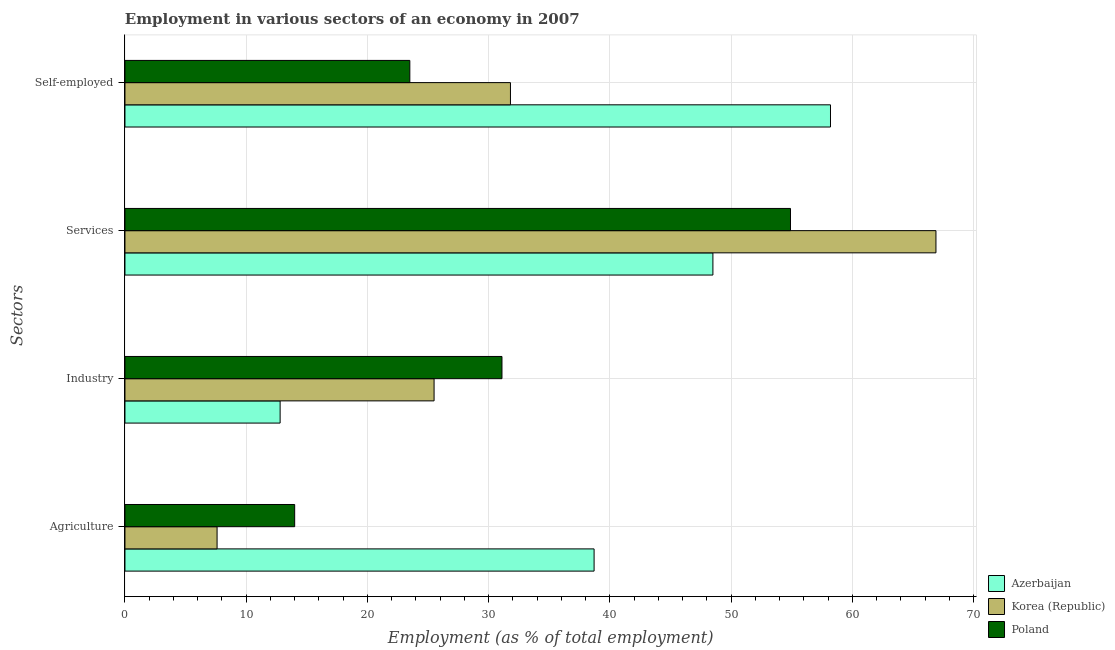How many different coloured bars are there?
Your answer should be very brief. 3. How many bars are there on the 1st tick from the bottom?
Your answer should be compact. 3. What is the label of the 1st group of bars from the top?
Ensure brevity in your answer.  Self-employed. What is the percentage of workers in agriculture in Poland?
Make the answer very short. 14. Across all countries, what is the maximum percentage of workers in agriculture?
Offer a terse response. 38.7. Across all countries, what is the minimum percentage of workers in agriculture?
Offer a terse response. 7.6. What is the total percentage of workers in agriculture in the graph?
Your response must be concise. 60.3. What is the difference between the percentage of workers in services in Korea (Republic) and that in Azerbaijan?
Your answer should be very brief. 18.4. What is the difference between the percentage of self employed workers in Poland and the percentage of workers in industry in Azerbaijan?
Your answer should be very brief. 10.7. What is the average percentage of workers in services per country?
Keep it short and to the point. 56.77. What is the difference between the percentage of workers in agriculture and percentage of self employed workers in Korea (Republic)?
Ensure brevity in your answer.  -24.2. What is the ratio of the percentage of workers in services in Korea (Republic) to that in Poland?
Your response must be concise. 1.22. Is the percentage of workers in industry in Poland less than that in Azerbaijan?
Your answer should be compact. No. Is the difference between the percentage of self employed workers in Poland and Azerbaijan greater than the difference between the percentage of workers in industry in Poland and Azerbaijan?
Your answer should be very brief. No. What is the difference between the highest and the second highest percentage of self employed workers?
Give a very brief answer. 26.4. What is the difference between the highest and the lowest percentage of workers in services?
Provide a short and direct response. 18.4. What does the 3rd bar from the top in Self-employed represents?
Your response must be concise. Azerbaijan. Is it the case that in every country, the sum of the percentage of workers in agriculture and percentage of workers in industry is greater than the percentage of workers in services?
Offer a terse response. No. Are all the bars in the graph horizontal?
Keep it short and to the point. Yes. Are the values on the major ticks of X-axis written in scientific E-notation?
Make the answer very short. No. Where does the legend appear in the graph?
Offer a very short reply. Bottom right. What is the title of the graph?
Give a very brief answer. Employment in various sectors of an economy in 2007. Does "Fragile and conflict affected situations" appear as one of the legend labels in the graph?
Your answer should be very brief. No. What is the label or title of the X-axis?
Give a very brief answer. Employment (as % of total employment). What is the label or title of the Y-axis?
Your answer should be compact. Sectors. What is the Employment (as % of total employment) in Azerbaijan in Agriculture?
Your answer should be compact. 38.7. What is the Employment (as % of total employment) of Korea (Republic) in Agriculture?
Ensure brevity in your answer.  7.6. What is the Employment (as % of total employment) of Azerbaijan in Industry?
Your answer should be compact. 12.8. What is the Employment (as % of total employment) in Poland in Industry?
Provide a succinct answer. 31.1. What is the Employment (as % of total employment) in Azerbaijan in Services?
Keep it short and to the point. 48.5. What is the Employment (as % of total employment) in Korea (Republic) in Services?
Offer a terse response. 66.9. What is the Employment (as % of total employment) of Poland in Services?
Keep it short and to the point. 54.9. What is the Employment (as % of total employment) in Azerbaijan in Self-employed?
Your answer should be very brief. 58.2. What is the Employment (as % of total employment) in Korea (Republic) in Self-employed?
Provide a short and direct response. 31.8. What is the Employment (as % of total employment) in Poland in Self-employed?
Give a very brief answer. 23.5. Across all Sectors, what is the maximum Employment (as % of total employment) of Azerbaijan?
Your response must be concise. 58.2. Across all Sectors, what is the maximum Employment (as % of total employment) in Korea (Republic)?
Provide a succinct answer. 66.9. Across all Sectors, what is the maximum Employment (as % of total employment) in Poland?
Provide a succinct answer. 54.9. Across all Sectors, what is the minimum Employment (as % of total employment) in Azerbaijan?
Your response must be concise. 12.8. Across all Sectors, what is the minimum Employment (as % of total employment) in Korea (Republic)?
Your answer should be compact. 7.6. Across all Sectors, what is the minimum Employment (as % of total employment) of Poland?
Provide a succinct answer. 14. What is the total Employment (as % of total employment) in Azerbaijan in the graph?
Ensure brevity in your answer.  158.2. What is the total Employment (as % of total employment) of Korea (Republic) in the graph?
Ensure brevity in your answer.  131.8. What is the total Employment (as % of total employment) of Poland in the graph?
Give a very brief answer. 123.5. What is the difference between the Employment (as % of total employment) in Azerbaijan in Agriculture and that in Industry?
Keep it short and to the point. 25.9. What is the difference between the Employment (as % of total employment) in Korea (Republic) in Agriculture and that in Industry?
Provide a succinct answer. -17.9. What is the difference between the Employment (as % of total employment) in Poland in Agriculture and that in Industry?
Provide a short and direct response. -17.1. What is the difference between the Employment (as % of total employment) of Korea (Republic) in Agriculture and that in Services?
Your answer should be compact. -59.3. What is the difference between the Employment (as % of total employment) of Poland in Agriculture and that in Services?
Offer a very short reply. -40.9. What is the difference between the Employment (as % of total employment) of Azerbaijan in Agriculture and that in Self-employed?
Offer a very short reply. -19.5. What is the difference between the Employment (as % of total employment) in Korea (Republic) in Agriculture and that in Self-employed?
Give a very brief answer. -24.2. What is the difference between the Employment (as % of total employment) in Azerbaijan in Industry and that in Services?
Provide a short and direct response. -35.7. What is the difference between the Employment (as % of total employment) in Korea (Republic) in Industry and that in Services?
Give a very brief answer. -41.4. What is the difference between the Employment (as % of total employment) of Poland in Industry and that in Services?
Your answer should be very brief. -23.8. What is the difference between the Employment (as % of total employment) in Azerbaijan in Industry and that in Self-employed?
Make the answer very short. -45.4. What is the difference between the Employment (as % of total employment) in Poland in Industry and that in Self-employed?
Your response must be concise. 7.6. What is the difference between the Employment (as % of total employment) of Azerbaijan in Services and that in Self-employed?
Your response must be concise. -9.7. What is the difference between the Employment (as % of total employment) in Korea (Republic) in Services and that in Self-employed?
Offer a very short reply. 35.1. What is the difference between the Employment (as % of total employment) in Poland in Services and that in Self-employed?
Give a very brief answer. 31.4. What is the difference between the Employment (as % of total employment) of Azerbaijan in Agriculture and the Employment (as % of total employment) of Poland in Industry?
Your answer should be compact. 7.6. What is the difference between the Employment (as % of total employment) in Korea (Republic) in Agriculture and the Employment (as % of total employment) in Poland in Industry?
Offer a terse response. -23.5. What is the difference between the Employment (as % of total employment) of Azerbaijan in Agriculture and the Employment (as % of total employment) of Korea (Republic) in Services?
Provide a short and direct response. -28.2. What is the difference between the Employment (as % of total employment) of Azerbaijan in Agriculture and the Employment (as % of total employment) of Poland in Services?
Ensure brevity in your answer.  -16.2. What is the difference between the Employment (as % of total employment) of Korea (Republic) in Agriculture and the Employment (as % of total employment) of Poland in Services?
Give a very brief answer. -47.3. What is the difference between the Employment (as % of total employment) of Korea (Republic) in Agriculture and the Employment (as % of total employment) of Poland in Self-employed?
Provide a succinct answer. -15.9. What is the difference between the Employment (as % of total employment) in Azerbaijan in Industry and the Employment (as % of total employment) in Korea (Republic) in Services?
Provide a succinct answer. -54.1. What is the difference between the Employment (as % of total employment) in Azerbaijan in Industry and the Employment (as % of total employment) in Poland in Services?
Offer a terse response. -42.1. What is the difference between the Employment (as % of total employment) of Korea (Republic) in Industry and the Employment (as % of total employment) of Poland in Services?
Provide a short and direct response. -29.4. What is the difference between the Employment (as % of total employment) in Azerbaijan in Industry and the Employment (as % of total employment) in Korea (Republic) in Self-employed?
Your answer should be very brief. -19. What is the difference between the Employment (as % of total employment) of Korea (Republic) in Industry and the Employment (as % of total employment) of Poland in Self-employed?
Offer a terse response. 2. What is the difference between the Employment (as % of total employment) in Azerbaijan in Services and the Employment (as % of total employment) in Korea (Republic) in Self-employed?
Make the answer very short. 16.7. What is the difference between the Employment (as % of total employment) of Korea (Republic) in Services and the Employment (as % of total employment) of Poland in Self-employed?
Keep it short and to the point. 43.4. What is the average Employment (as % of total employment) of Azerbaijan per Sectors?
Make the answer very short. 39.55. What is the average Employment (as % of total employment) in Korea (Republic) per Sectors?
Provide a short and direct response. 32.95. What is the average Employment (as % of total employment) of Poland per Sectors?
Make the answer very short. 30.88. What is the difference between the Employment (as % of total employment) in Azerbaijan and Employment (as % of total employment) in Korea (Republic) in Agriculture?
Your answer should be compact. 31.1. What is the difference between the Employment (as % of total employment) in Azerbaijan and Employment (as % of total employment) in Poland in Agriculture?
Provide a succinct answer. 24.7. What is the difference between the Employment (as % of total employment) in Azerbaijan and Employment (as % of total employment) in Korea (Republic) in Industry?
Keep it short and to the point. -12.7. What is the difference between the Employment (as % of total employment) in Azerbaijan and Employment (as % of total employment) in Poland in Industry?
Keep it short and to the point. -18.3. What is the difference between the Employment (as % of total employment) of Korea (Republic) and Employment (as % of total employment) of Poland in Industry?
Keep it short and to the point. -5.6. What is the difference between the Employment (as % of total employment) of Azerbaijan and Employment (as % of total employment) of Korea (Republic) in Services?
Your response must be concise. -18.4. What is the difference between the Employment (as % of total employment) in Korea (Republic) and Employment (as % of total employment) in Poland in Services?
Ensure brevity in your answer.  12. What is the difference between the Employment (as % of total employment) in Azerbaijan and Employment (as % of total employment) in Korea (Republic) in Self-employed?
Your answer should be compact. 26.4. What is the difference between the Employment (as % of total employment) in Azerbaijan and Employment (as % of total employment) in Poland in Self-employed?
Offer a very short reply. 34.7. What is the ratio of the Employment (as % of total employment) in Azerbaijan in Agriculture to that in Industry?
Make the answer very short. 3.02. What is the ratio of the Employment (as % of total employment) of Korea (Republic) in Agriculture to that in Industry?
Provide a short and direct response. 0.3. What is the ratio of the Employment (as % of total employment) of Poland in Agriculture to that in Industry?
Your response must be concise. 0.45. What is the ratio of the Employment (as % of total employment) in Azerbaijan in Agriculture to that in Services?
Your response must be concise. 0.8. What is the ratio of the Employment (as % of total employment) of Korea (Republic) in Agriculture to that in Services?
Provide a short and direct response. 0.11. What is the ratio of the Employment (as % of total employment) in Poland in Agriculture to that in Services?
Make the answer very short. 0.26. What is the ratio of the Employment (as % of total employment) in Azerbaijan in Agriculture to that in Self-employed?
Keep it short and to the point. 0.66. What is the ratio of the Employment (as % of total employment) of Korea (Republic) in Agriculture to that in Self-employed?
Provide a short and direct response. 0.24. What is the ratio of the Employment (as % of total employment) of Poland in Agriculture to that in Self-employed?
Give a very brief answer. 0.6. What is the ratio of the Employment (as % of total employment) in Azerbaijan in Industry to that in Services?
Ensure brevity in your answer.  0.26. What is the ratio of the Employment (as % of total employment) in Korea (Republic) in Industry to that in Services?
Your answer should be very brief. 0.38. What is the ratio of the Employment (as % of total employment) of Poland in Industry to that in Services?
Your answer should be very brief. 0.57. What is the ratio of the Employment (as % of total employment) in Azerbaijan in Industry to that in Self-employed?
Keep it short and to the point. 0.22. What is the ratio of the Employment (as % of total employment) of Korea (Republic) in Industry to that in Self-employed?
Make the answer very short. 0.8. What is the ratio of the Employment (as % of total employment) in Poland in Industry to that in Self-employed?
Keep it short and to the point. 1.32. What is the ratio of the Employment (as % of total employment) in Korea (Republic) in Services to that in Self-employed?
Keep it short and to the point. 2.1. What is the ratio of the Employment (as % of total employment) of Poland in Services to that in Self-employed?
Make the answer very short. 2.34. What is the difference between the highest and the second highest Employment (as % of total employment) in Korea (Republic)?
Provide a short and direct response. 35.1. What is the difference between the highest and the second highest Employment (as % of total employment) of Poland?
Ensure brevity in your answer.  23.8. What is the difference between the highest and the lowest Employment (as % of total employment) in Azerbaijan?
Your response must be concise. 45.4. What is the difference between the highest and the lowest Employment (as % of total employment) of Korea (Republic)?
Ensure brevity in your answer.  59.3. What is the difference between the highest and the lowest Employment (as % of total employment) of Poland?
Provide a short and direct response. 40.9. 